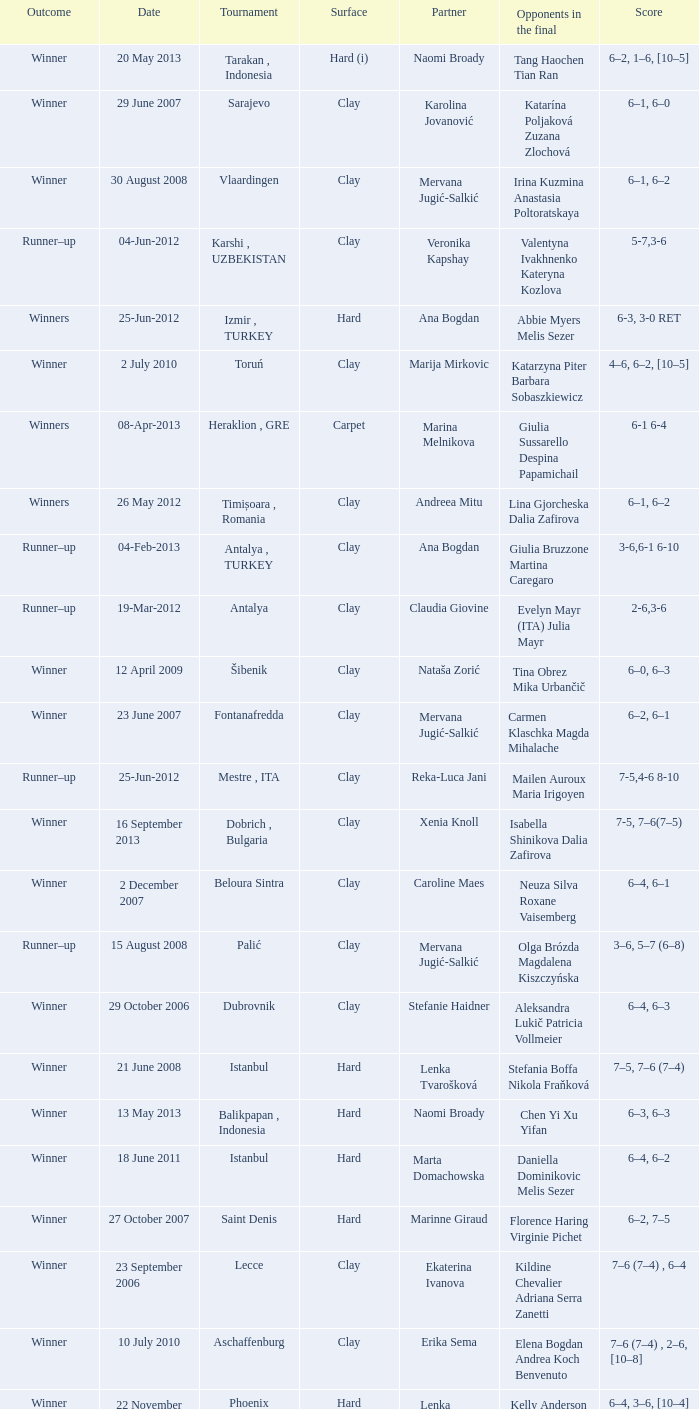Who were the opponents in the final at Noida? Kelly Anderson Chanelle Scheepers. 